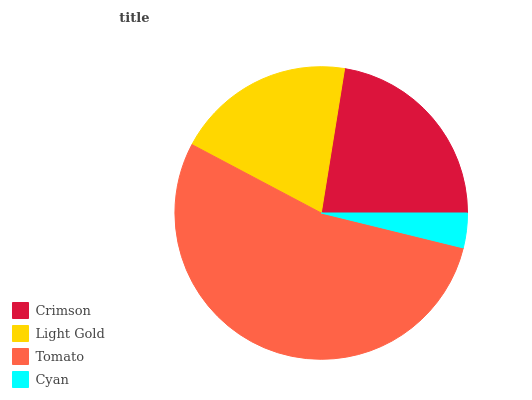Is Cyan the minimum?
Answer yes or no. Yes. Is Tomato the maximum?
Answer yes or no. Yes. Is Light Gold the minimum?
Answer yes or no. No. Is Light Gold the maximum?
Answer yes or no. No. Is Crimson greater than Light Gold?
Answer yes or no. Yes. Is Light Gold less than Crimson?
Answer yes or no. Yes. Is Light Gold greater than Crimson?
Answer yes or no. No. Is Crimson less than Light Gold?
Answer yes or no. No. Is Crimson the high median?
Answer yes or no. Yes. Is Light Gold the low median?
Answer yes or no. Yes. Is Tomato the high median?
Answer yes or no. No. Is Tomato the low median?
Answer yes or no. No. 